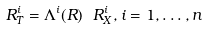<formula> <loc_0><loc_0><loc_500><loc_500>R _ { T } ^ { i } = \Lambda ^ { i } ( R ) \ R ^ { i } _ { X } , i = 1 , \dots , n</formula> 